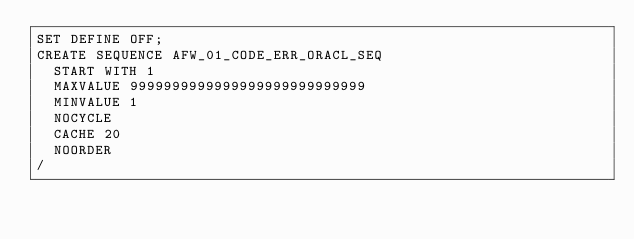<code> <loc_0><loc_0><loc_500><loc_500><_SQL_>SET DEFINE OFF;
CREATE SEQUENCE AFW_01_CODE_ERR_ORACL_SEQ
  START WITH 1
  MAXVALUE 9999999999999999999999999999
  MINVALUE 1
  NOCYCLE
  CACHE 20
  NOORDER
/
</code> 